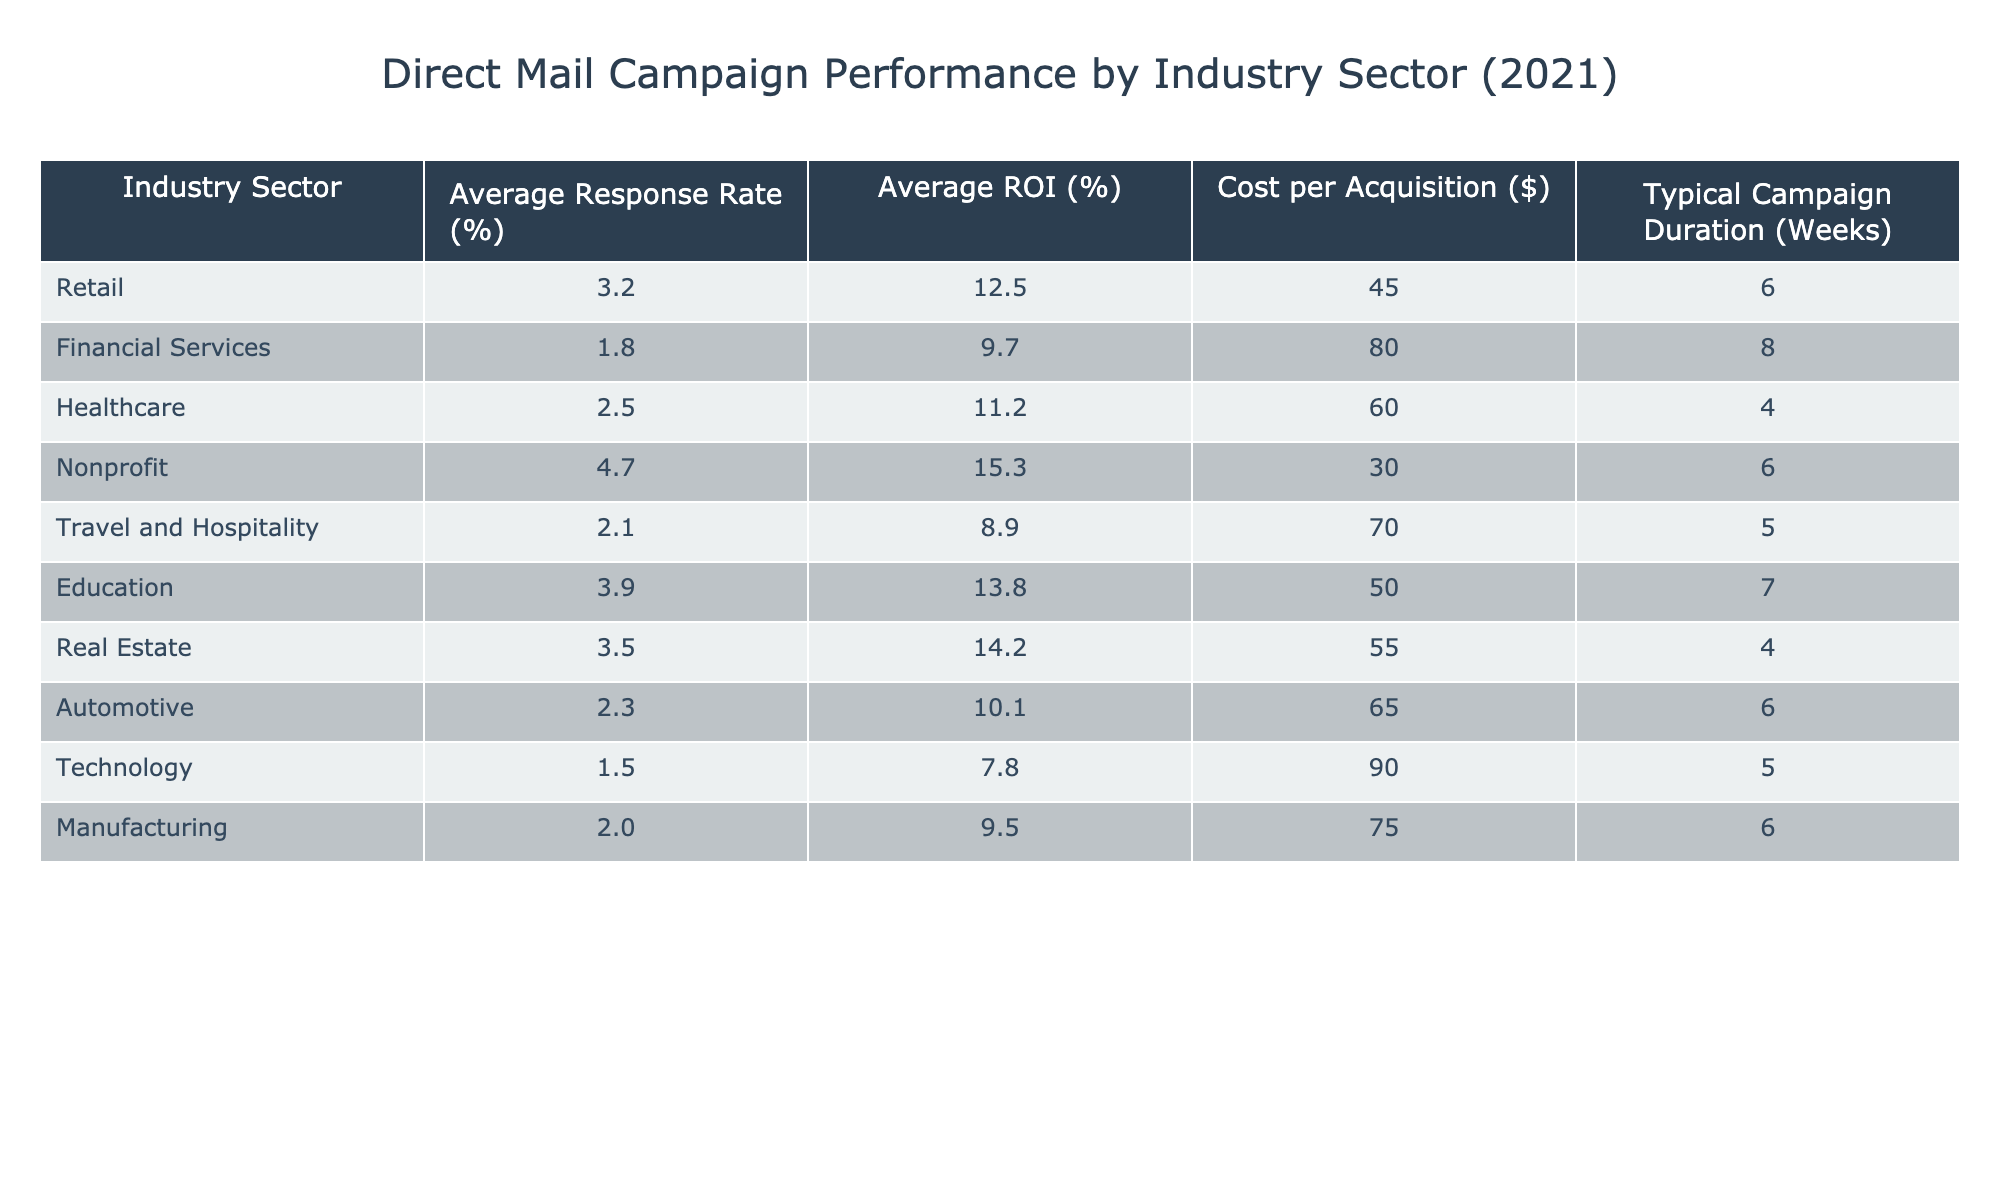What is the average response rate for the nonprofit sector? The table shows that the average response rate for the nonprofit sector is listed directly under that column, which is 4.7%.
Answer: 4.7% Which industry sector has the highest average ROI? Looking at the average ROI column, the highest value is 15.3%, which corresponds to the nonprofit sector.
Answer: Nonprofit What is the cost per acquisition for the technology sector? The cost per acquisition for the technology sector can be found in the table, specifically under its respective column, and it is $90.
Answer: $90 Calculate the average response rate for the retail and education sectors combined. The average response rates for retail and education are 3.2% and 3.9% respectively. To find the average, add them together: 3.2 + 3.9 = 7.1, then divide by 2 to get 7.1 / 2 = 3.55%.
Answer: 3.55% Is the average cost per acquisition for healthcare higher than that for manufacturing? The cost per acquisition for healthcare is $60, while for manufacturing it is $75. Since 60 is less than 75, the statement is false.
Answer: No Which industry sector has the longest typical campaign duration? The typical campaign duration can be scanned in the table; the maximum duration is 8 weeks, found in the financial services sector.
Answer: Financial Services What is the difference in average response rates between the travel and hospitality sector and the nonprofit sector? The average response rate for travel and hospitality is 2.1%, and for nonprofit, it's 4.7%. To find the difference: 4.7 - 2.1 = 2.6%.
Answer: 2.6% Which sector has the lowest average response rate? The lowest average response rate can be identified from the table, and it belongs to the technology sector at 1.5%.
Answer: Technology If the average cost per acquisition for the automotive sector is $65, what is the total cost if a campaign targets 100 individuals? The cost per acquisition for automotive is actually $65 (not the stated $60), so multiplying $65 by 100 provides the total cost: 65 * 100 = $6500.
Answer: $6500 Is the average ROI for the education sector greater than the average ROI for the healthcare sector? The average ROI for education is 13.8%, while for healthcare, it is 11.2%. Since 13.8% is greater than 11.2%, the statement is true.
Answer: Yes 